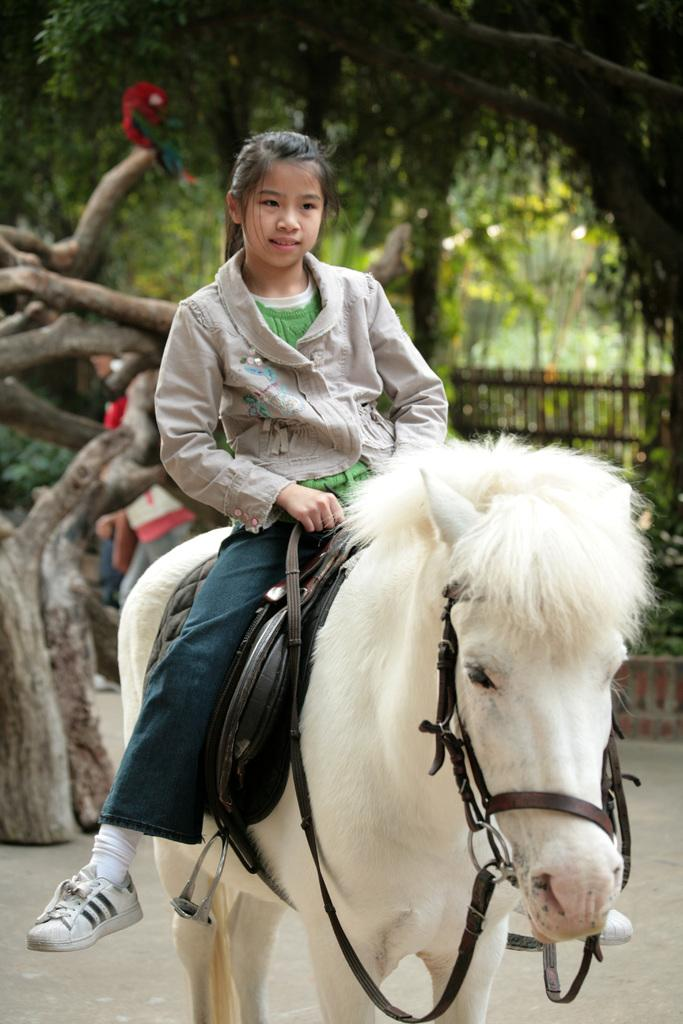What animal can be seen in the image? There is a white horse in the image. Who is on the horse? A girl is sitting on the horse. What can be seen in the background of the image? There are trees visible at the top of the image. What type of holiday is being celebrated in the image? There is no indication of a holiday being celebrated in the image. What is the texture of the horse's coat in the image? The provided facts do not mention the texture of the horse's coat, so it cannot be determined from the image. 